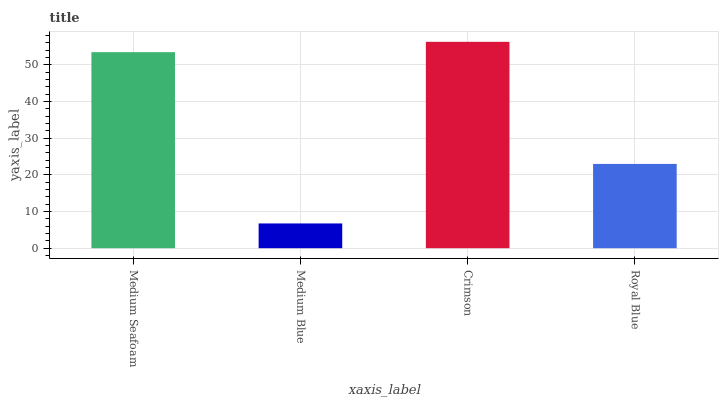Is Medium Blue the minimum?
Answer yes or no. Yes. Is Crimson the maximum?
Answer yes or no. Yes. Is Crimson the minimum?
Answer yes or no. No. Is Medium Blue the maximum?
Answer yes or no. No. Is Crimson greater than Medium Blue?
Answer yes or no. Yes. Is Medium Blue less than Crimson?
Answer yes or no. Yes. Is Medium Blue greater than Crimson?
Answer yes or no. No. Is Crimson less than Medium Blue?
Answer yes or no. No. Is Medium Seafoam the high median?
Answer yes or no. Yes. Is Royal Blue the low median?
Answer yes or no. Yes. Is Crimson the high median?
Answer yes or no. No. Is Medium Blue the low median?
Answer yes or no. No. 